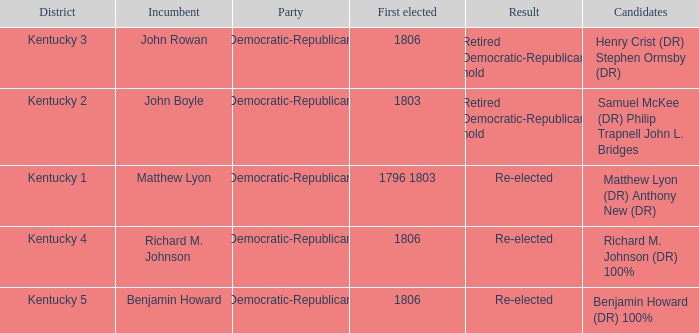Name the first elected for kentucky 3 1806.0. 